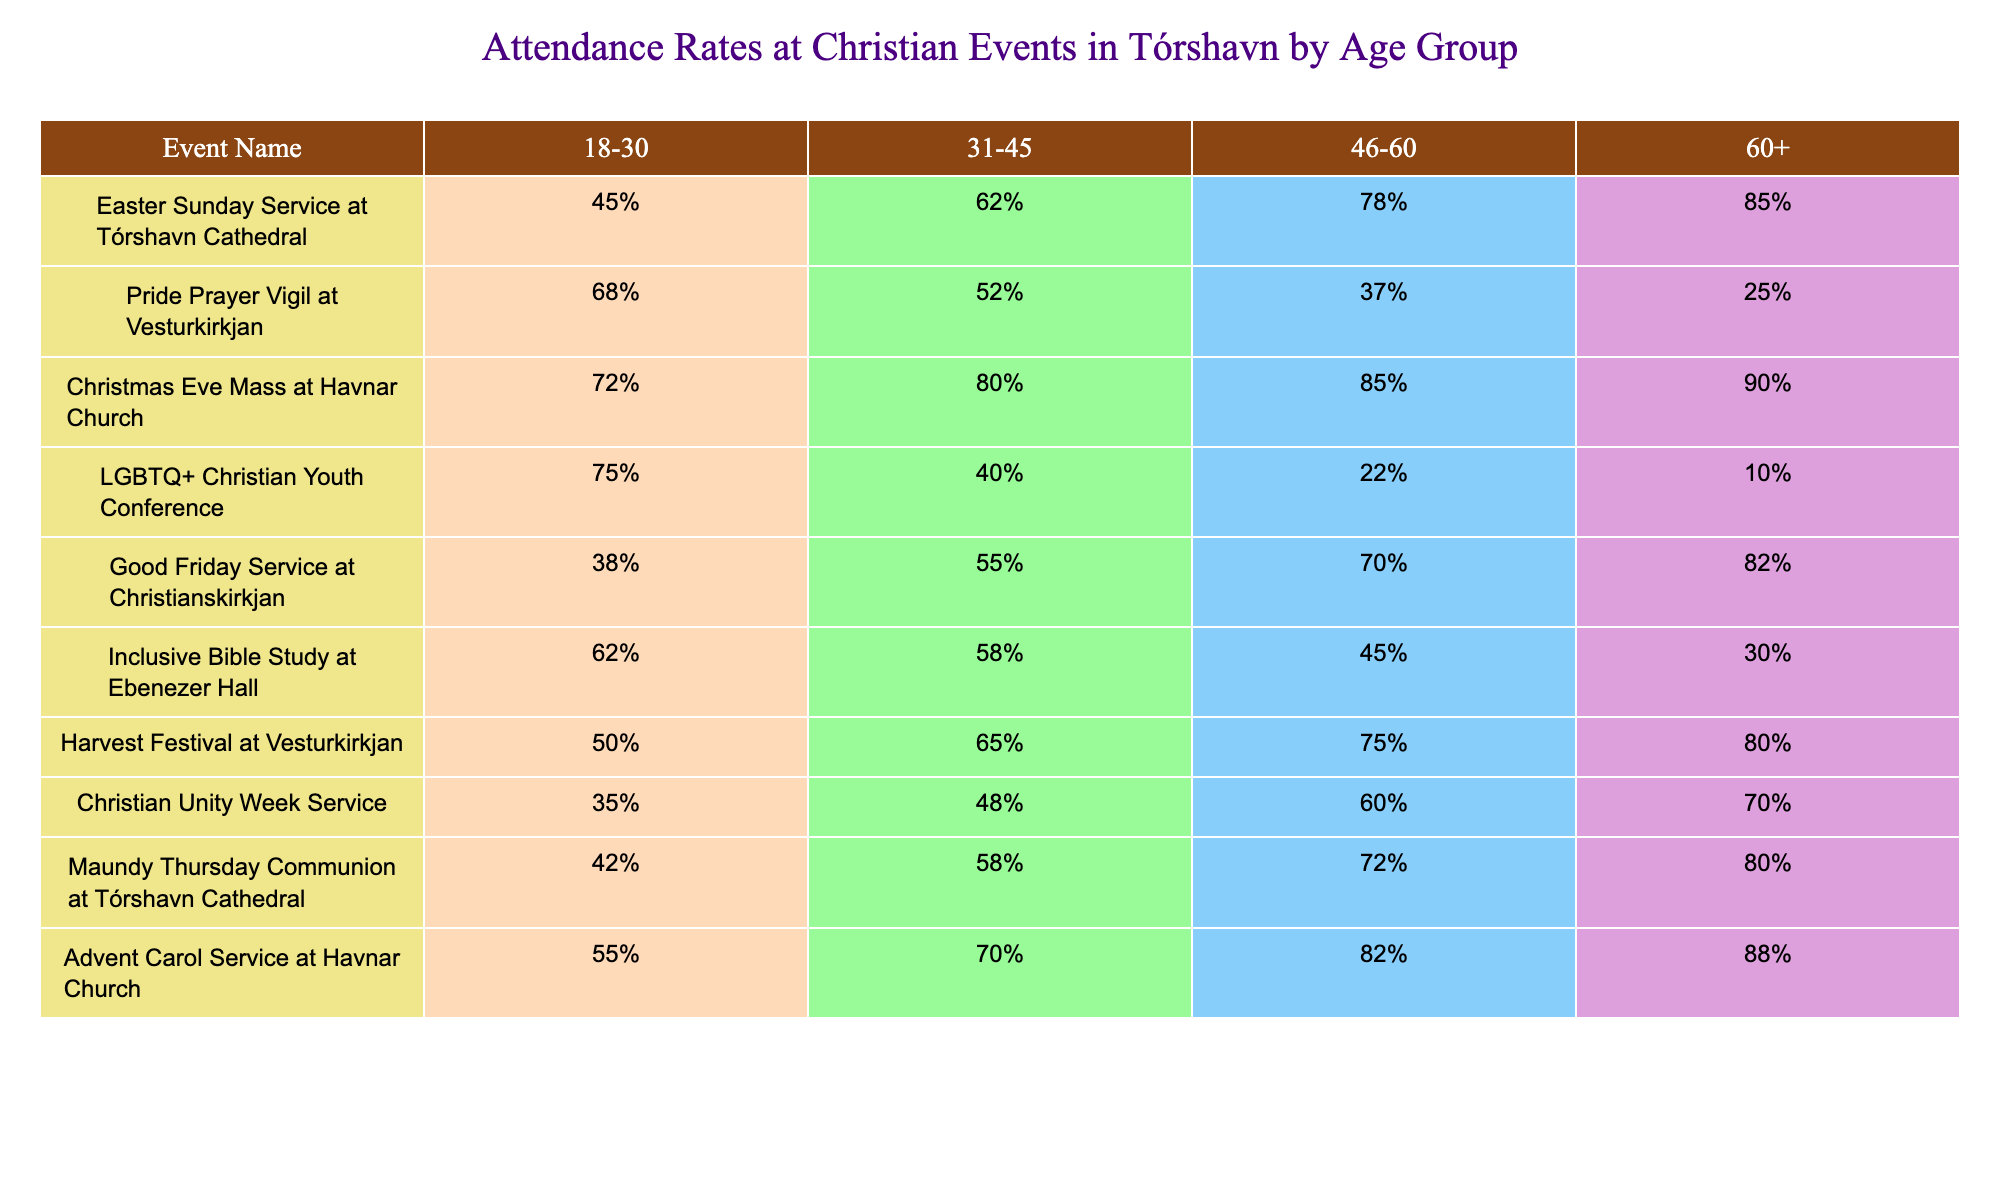What is the attendance rate for the "Pride Prayer Vigil" among the 18-30 age group? The table shows that the attendance rate for the "Pride Prayer Vigil" under the 18-30 age group is 68%.
Answer: 68% Which event has the highest attendance rate among those aged 60 and over? By comparing the 60+ column for each event, the "Christmas Eve Mass" has the highest attendance rate of 90% among this age group.
Answer: 90% What is the average attendance rate for the "LGBTQ+ Christian Youth Conference" across all age groups? The attendance rates for the "LGBTQ+ Christian Youth Conference" are 75%, 40%, 22%, and 10% for age groups 18-30, 31-45, 46-60, and 60+, respectively. Adding these rates gives 75 + 40 + 22 + 10 = 147, and dividing by 4 gives an average of 36.75%.
Answer: 36.75% Is the attendance rate for the "Easter Sunday Service" higher among the 46-60 age group compared to the "Good Friday Service"? The attendance rate for the "Easter Sunday Service" in the 46-60 age group is 78%, while the "Good Friday Service" has 70% for the same group. Since 78% is greater than 70%, the statement is true.
Answer: Yes What is the difference in attendance rates between the "Advent Carol Service" and the "Inclusive Bible Study" for the age group 31-45? The attendance for the "Advent Carol Service" is 70% for the 31-45 age group, and for the "Inclusive Bible Study", it is 58%. The difference is 70% - 58% = 12%.
Answer: 12% Which age group shows the most significant decline in attendance from the "Christmas Eve Mass" to the "LGBTQ+ Christian Youth Conference"? The attendance for "Christmas Eve Mass" for 31-45 is 80%, and for the "LGBTQ+ Christian Youth Conference" it is 40%. The decline is 80% - 40% = 40%. For 46-60, "Christmas Eve Mass" is 85% and "LGBTQ+ Christian Youth Conference" is 22%, a decline of 63%. Comparing the two declines, 63% is greater than 40%, indicating a significant decline among 46-60 as opposed to 31-45.
Answer: 63% What percentage of attendees above 60 years old prefer the "Harvest Festival" over the "Pride Prayer Vigil"? The attendance rate for the "Harvest Festival" among those aged 60+ is 80%, and for the "Pride Prayer Vigil", it is 25%. The percentage difference is 80% - 25% = 55%.
Answer: 55% What could be inferred about the interest of the 18-30 age group in the "Good Friday Service" compared to other events they attended? The "Good Friday Service" has an attendance rate of 38% for the 18-30 age group, which is lower than other events they attended like "Pride Prayer Vigil" (68%) and "LGBTQ+ Christian Youth Conference" (75%). This suggests that the 18-30 age group shows less interest in the "Good Friday Service".
Answer: Low interest Which event, on average, sees more attendance from older groups (46-60 and 60+) combined? To find the average attendance for older groups across all events, we sum up the attendance rates for both 46-60 and 60+ age groups, and take the average. The average for older groups can be calculated, but a quick look reveals that the "Christmas Eve Mass" has 85% + 90%, while "Good Friday Service" has 70% + 82%. The "Christmas Eve Mass" retains the highest average among the events.
Answer: "Christmas Eve Mass" 